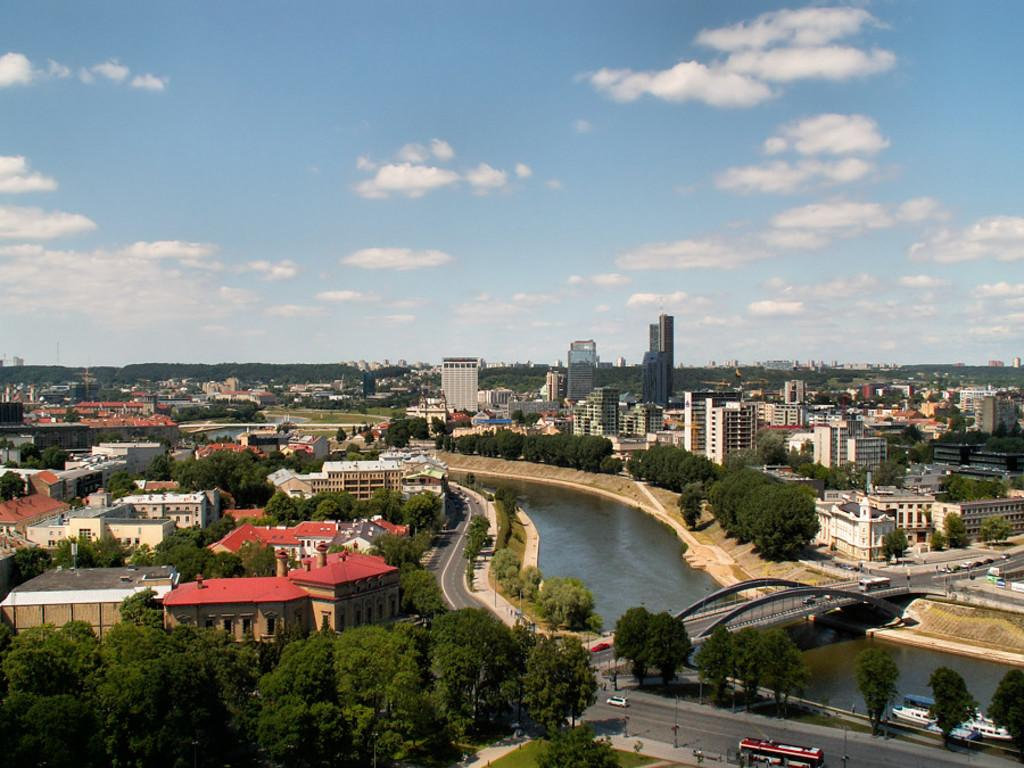What type of structures can be seen in the image? There are many buildings in the image. What other natural elements are present in the image? There are trees in the image. What type of man-made structure connects the two sides of the river? There is a bridge in the image. What body of water is visible in the image? There is a river in the image. What type of transportation can be seen on the road? There are vehicles on the road in the image. What is visible at the top of the image? The sky is visible at the top of the image. What can be seen in the sky? There are clouds in the sky. What type of curtain is hanging in the jail cell in the image? There is no jail or curtain present in the image. What type of industry is depicted in the image? There is no specific industry depicted in the image; it shows a general urban landscape with buildings, trees, a bridge, a river, vehicles, and the sky. 